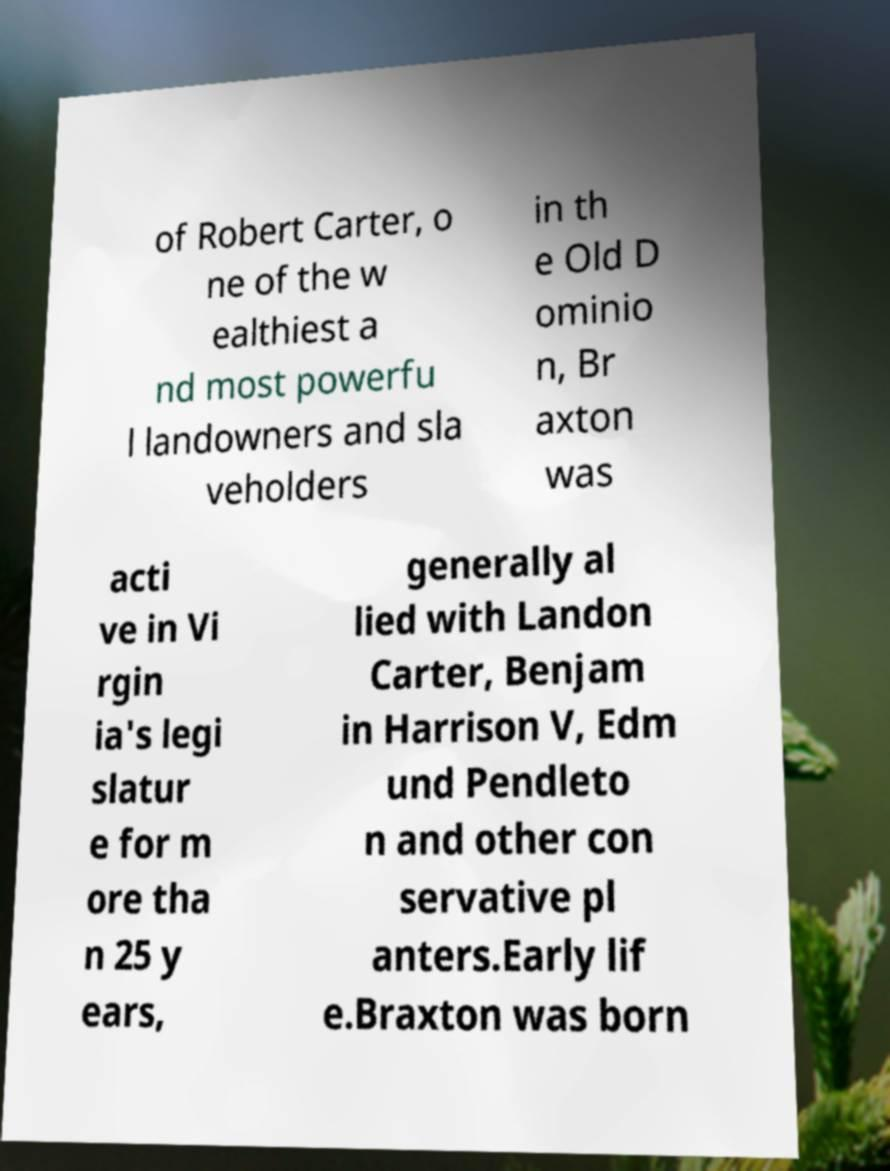I need the written content from this picture converted into text. Can you do that? of Robert Carter, o ne of the w ealthiest a nd most powerfu l landowners and sla veholders in th e Old D ominio n, Br axton was acti ve in Vi rgin ia's legi slatur e for m ore tha n 25 y ears, generally al lied with Landon Carter, Benjam in Harrison V, Edm und Pendleto n and other con servative pl anters.Early lif e.Braxton was born 